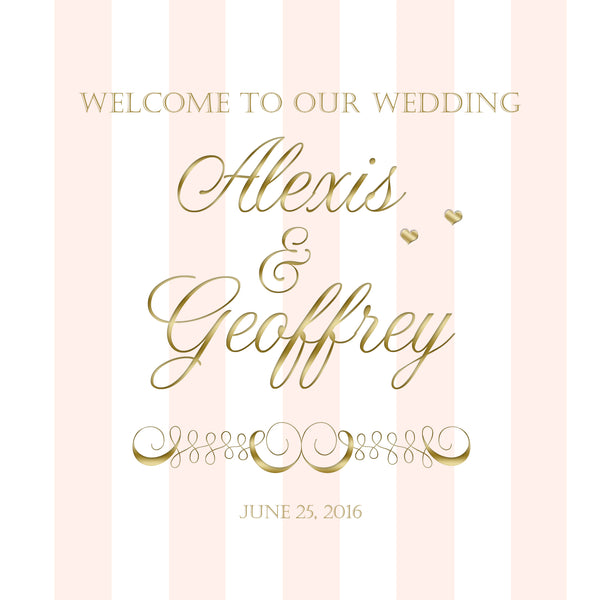Considering the color scheme of pink and gold, what type of flowers might be chosen for the wedding decor? With the pink and gold color scheme, the couple might choose flowers like blush pink roses, peonies, and hydrangeas to complement the soft and romantic feel. To add a hint of gold, they might include flowers with gold-dusted petals or use gold vases and accents in the floral arrangements. 